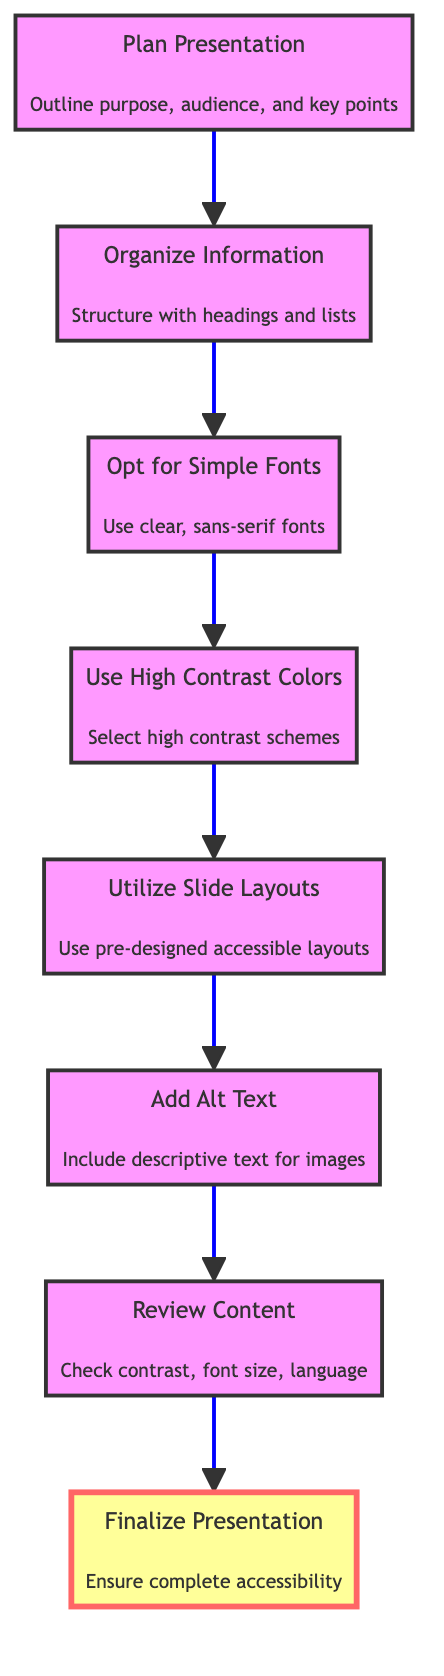What is the first step in the flow chart? According to the flow chart, the first step to perform is "Plan Presentation," as it is the bottom-most node that initiates the flow towards finalizing the presentation.
Answer: Plan Presentation How many nodes are present in the flow chart? The flow chart contains a total of eight nodes, each representing a step in the process of creating an accessible PowerPoint presentation.
Answer: Eight What is the last step before finalizing the presentation? After reviewing the content, the final step to perform before finalizing the presentation is to ensure that the presentation is complete and accessible, which is indicated by the node "Finalize Presentation."
Answer: Review Content Which step emphasizes the use of high contrast colors? The flow chart indicates that the step emphasizing high contrast colors is "Use High Contrast Colors," which directly precedes the utilization of slide layouts.
Answer: Use High Contrast Colors What do you do after organizing information? Once information is organized, the next step outlined in the flow chart is to "Opt for Simple Fonts," helping ensure readability by selecting clear font types.
Answer: Opt for Simple Fonts Is "Add Alt Text" before or after "Utilize Slide Layouts"? In the flow of the chart, "Add Alt Text" follows "Utilize Slide Layouts," indicating that alt text should be added after the slide layouts have been utilized for accessibility.
Answer: After How is the flow directed in this diagram? The diagram follows a bottom-to-top direction indicating a sequential process moving from planning through to finalizing the presentation, with each step building on the previous one.
Answer: Bottom to top What is the relationship between “Plan Presentation” and “Review Content”? "Plan Presentation" leads to "Organize Information," followed by a series of steps that culminate in "Review Content," thus establishing that planning is foundational to reviewing the content.
Answer: Planning leads to reviewing 